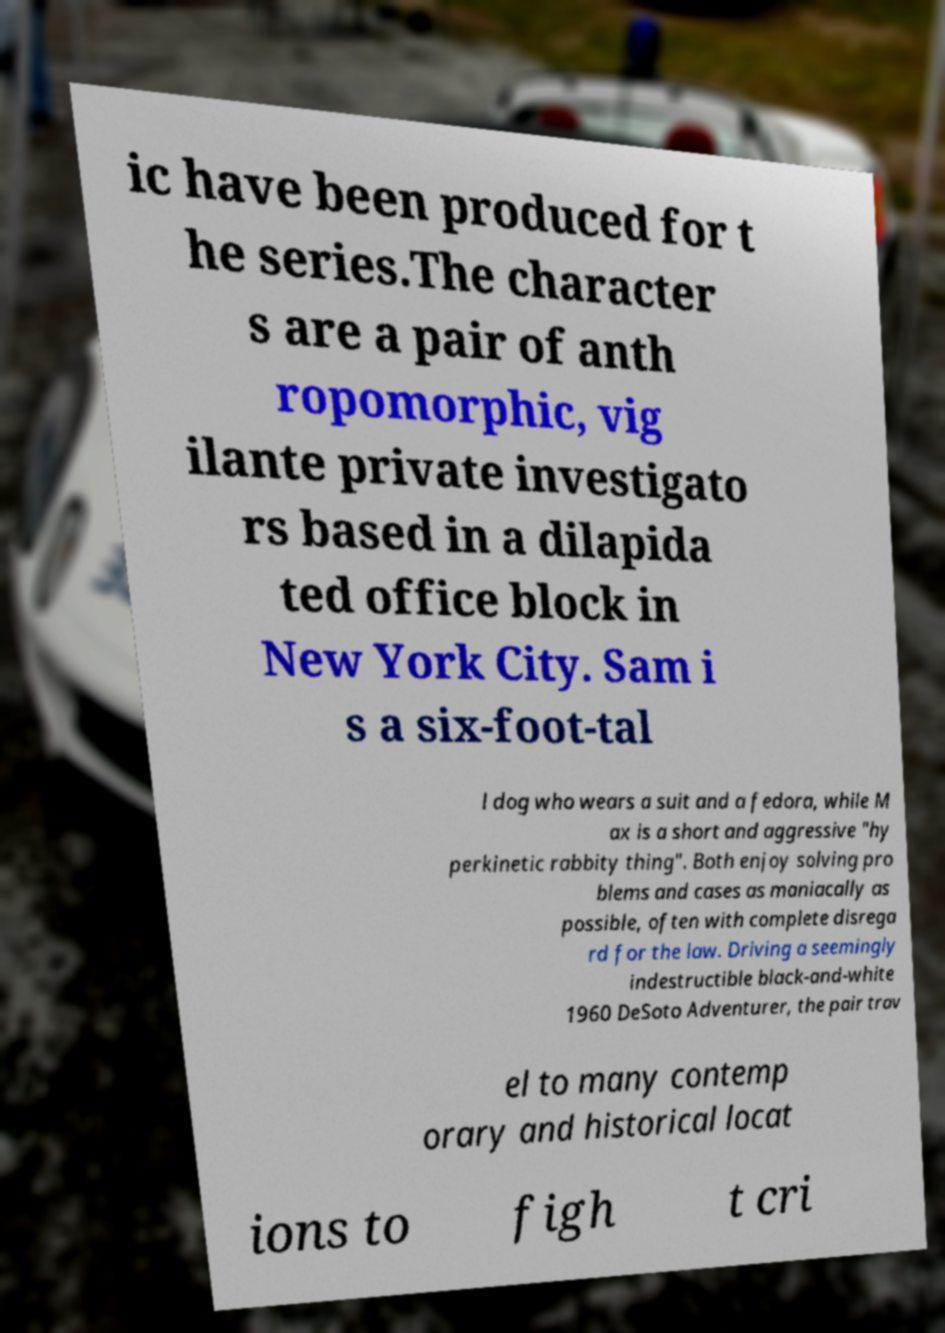Can you read and provide the text displayed in the image?This photo seems to have some interesting text. Can you extract and type it out for me? ic have been produced for t he series.The character s are a pair of anth ropomorphic, vig ilante private investigato rs based in a dilapida ted office block in New York City. Sam i s a six-foot-tal l dog who wears a suit and a fedora, while M ax is a short and aggressive "hy perkinetic rabbity thing". Both enjoy solving pro blems and cases as maniacally as possible, often with complete disrega rd for the law. Driving a seemingly indestructible black-and-white 1960 DeSoto Adventurer, the pair trav el to many contemp orary and historical locat ions to figh t cri 